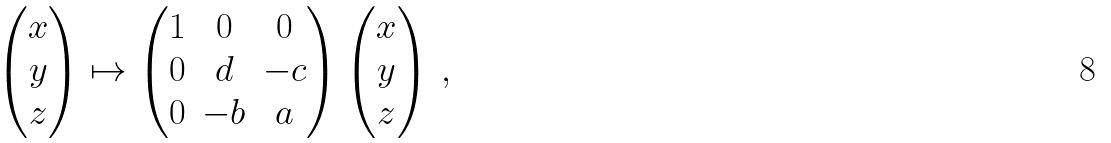Convert formula to latex. <formula><loc_0><loc_0><loc_500><loc_500>\begin{pmatrix} x \\ y \\ z \end{pmatrix} \mapsto \begin{pmatrix} 1 & 0 & 0 \\ 0 & d & - c \\ 0 & - b & a \end{pmatrix} \begin{pmatrix} x \\ y \\ z \end{pmatrix} \, ,</formula> 